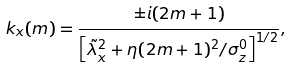Convert formula to latex. <formula><loc_0><loc_0><loc_500><loc_500>k _ { x } ( m ) = \frac { \pm i ( 2 m + 1 ) } { \left [ { \tilde { \lambda } } _ { x } ^ { 2 } + \eta ( 2 m + 1 ) ^ { 2 } / \sigma _ { z } ^ { 0 } \right ] ^ { 1 / 2 } } ,</formula> 